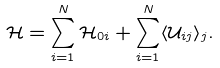Convert formula to latex. <formula><loc_0><loc_0><loc_500><loc_500>\mathcal { H } = \sum _ { i = 1 } ^ { N } \mathcal { H } _ { 0 i } + \sum _ { i = 1 } ^ { N } \langle \mathcal { U } _ { i j } \rangle _ { j } .</formula> 